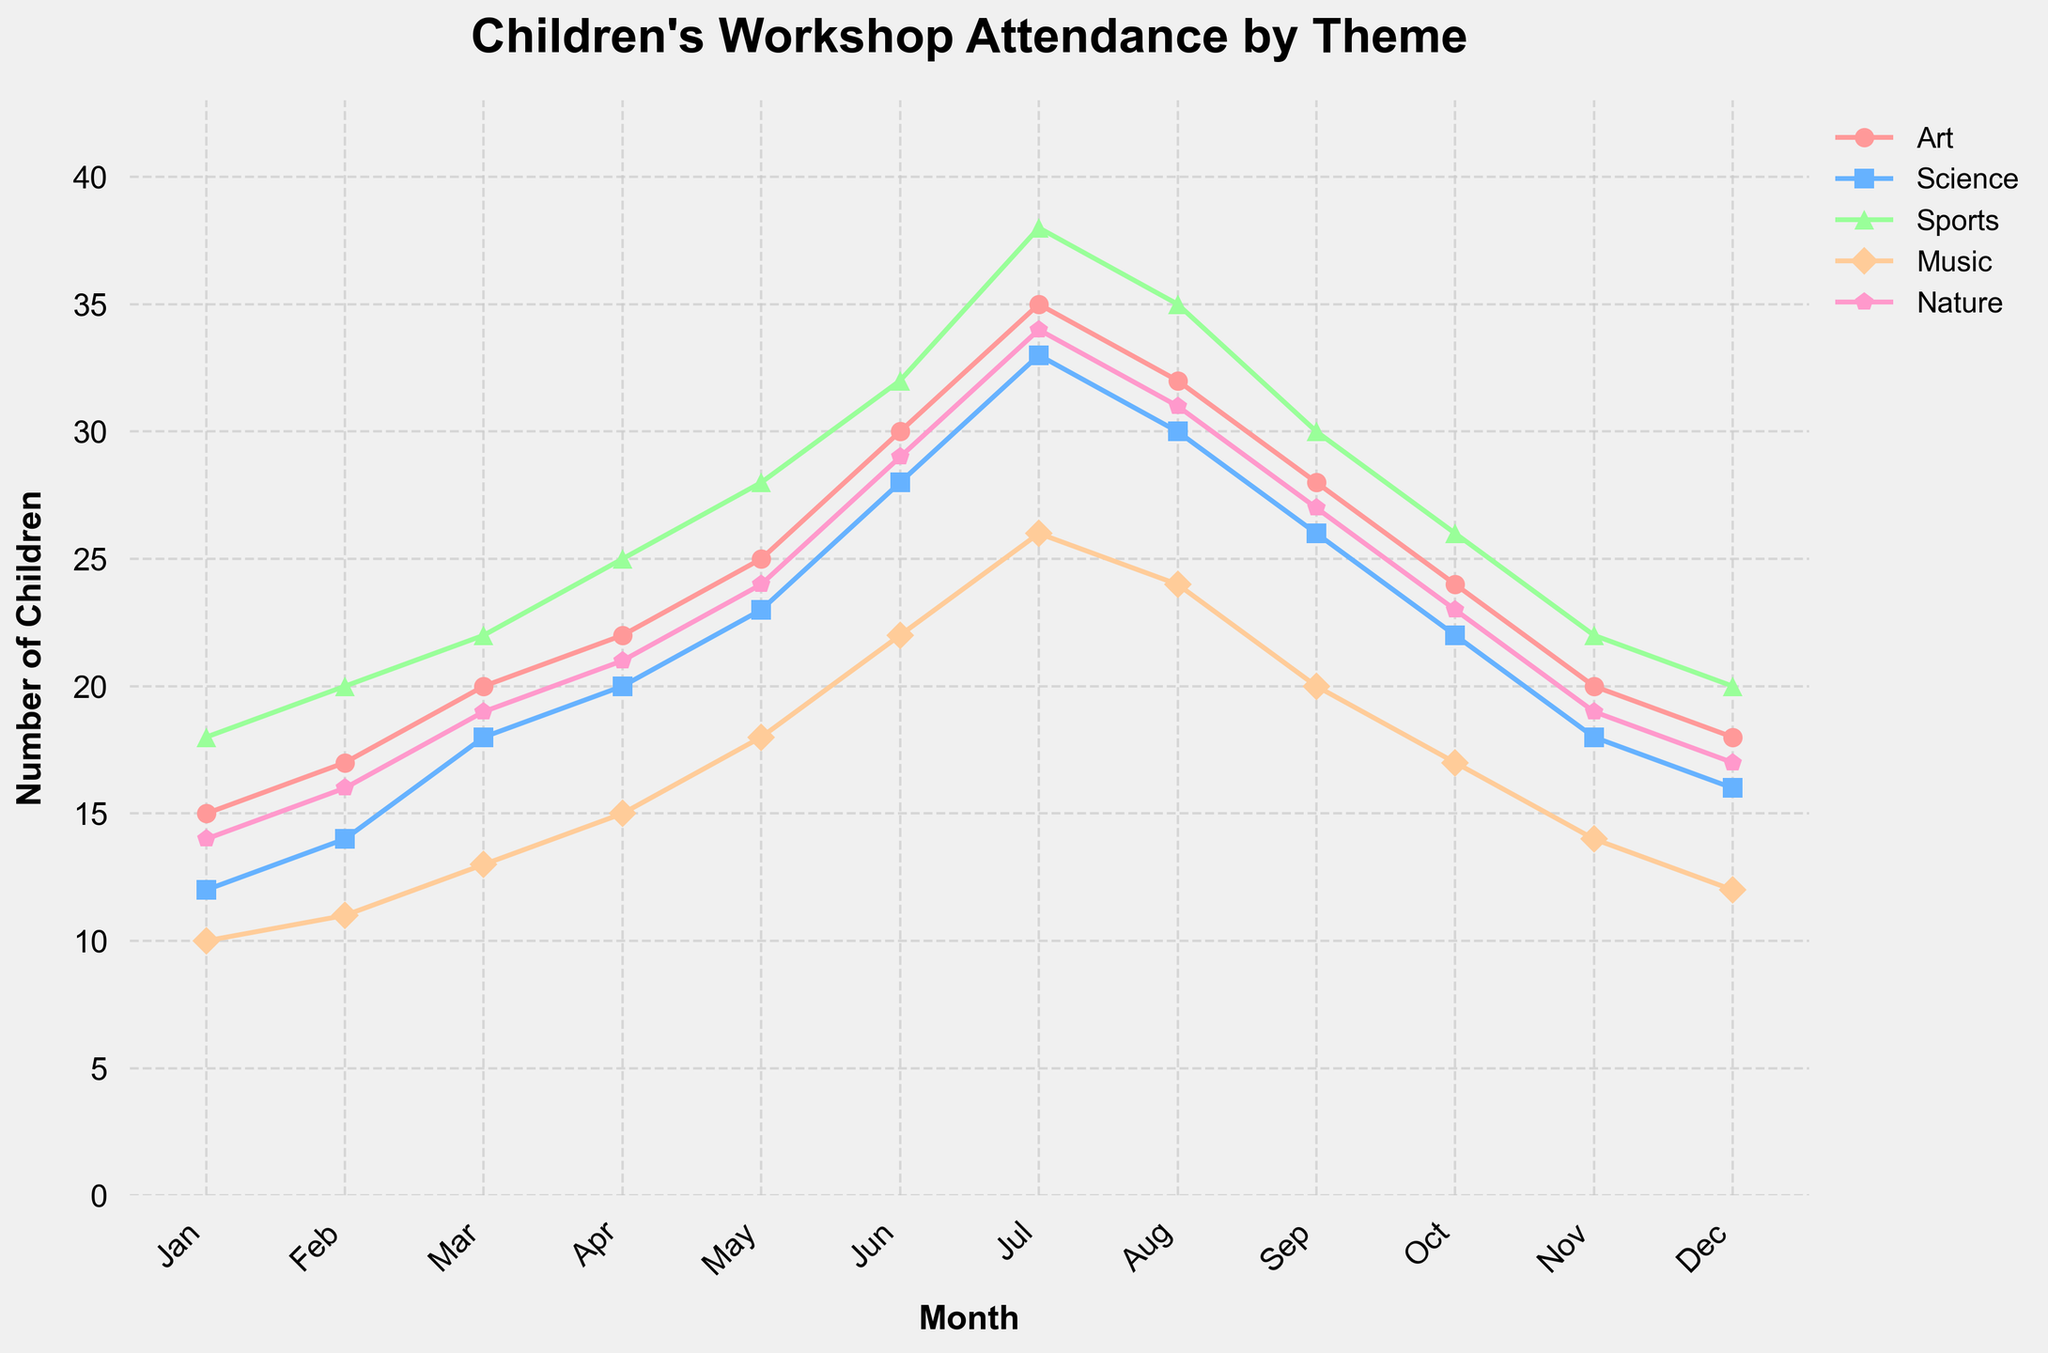What is the maximum number of children attending the Art workshop in July? In July, the line corresponding to the Art workshop peaks at the highest point. By checking the y-axis value at this point, we can see it reaches 35.
Answer: 35 Which month shows the highest attendance for the Sports workshop? The line representing Sports attendance peaks in July. By viewing the y-axis value in July, we observe that it's in the highest position for that month.
Answer: July How does the attendance of the Music workshop in March compare to that in June? In March, the Music workshop shows 13 children, and in June, it shows 22 children. Comparing these, 22 is greater than 13, indicating an increase in June.
Answer: June has higher attendance By how much does the attendance for the Science workshop increase from January to March? The Science workshop's attendance in January is 12, increasing to 18 by March. Subtracting January's value from March's gives 18 - 12 = 6.
Answer: 6 Which workshop had the least attendance in December? By looking at December, the Music workshop has the lowest point among all lines, touching the y-axis at 12.
Answer: Music What is the average attendance for the Nature workshop over the year? Sum all values for the Nature workshop (14+16+19+21+24+29+34+31+27+23+19+17) = 274. Divide by 12, the number of months: 274 / 12 ≈ 22.83.
Answer: 22.83 Did any month have exactly equal attendance for any two workshops? By scanning the lines month by month, February shows the Art and Sports workshops both have attendance of 20.
Answer: February What was the difference in attendance between the Nature and Science workshops in August? In August, Nature has 31 children, Science has 30. Subtracting these two: 31 - 30 = 1.
Answer: 1 Which workshop showed a decline in attendance from July to August? Observing the trends, Art decreases from 35 in July to 32 in August, indicating a drop.
Answer: Art 